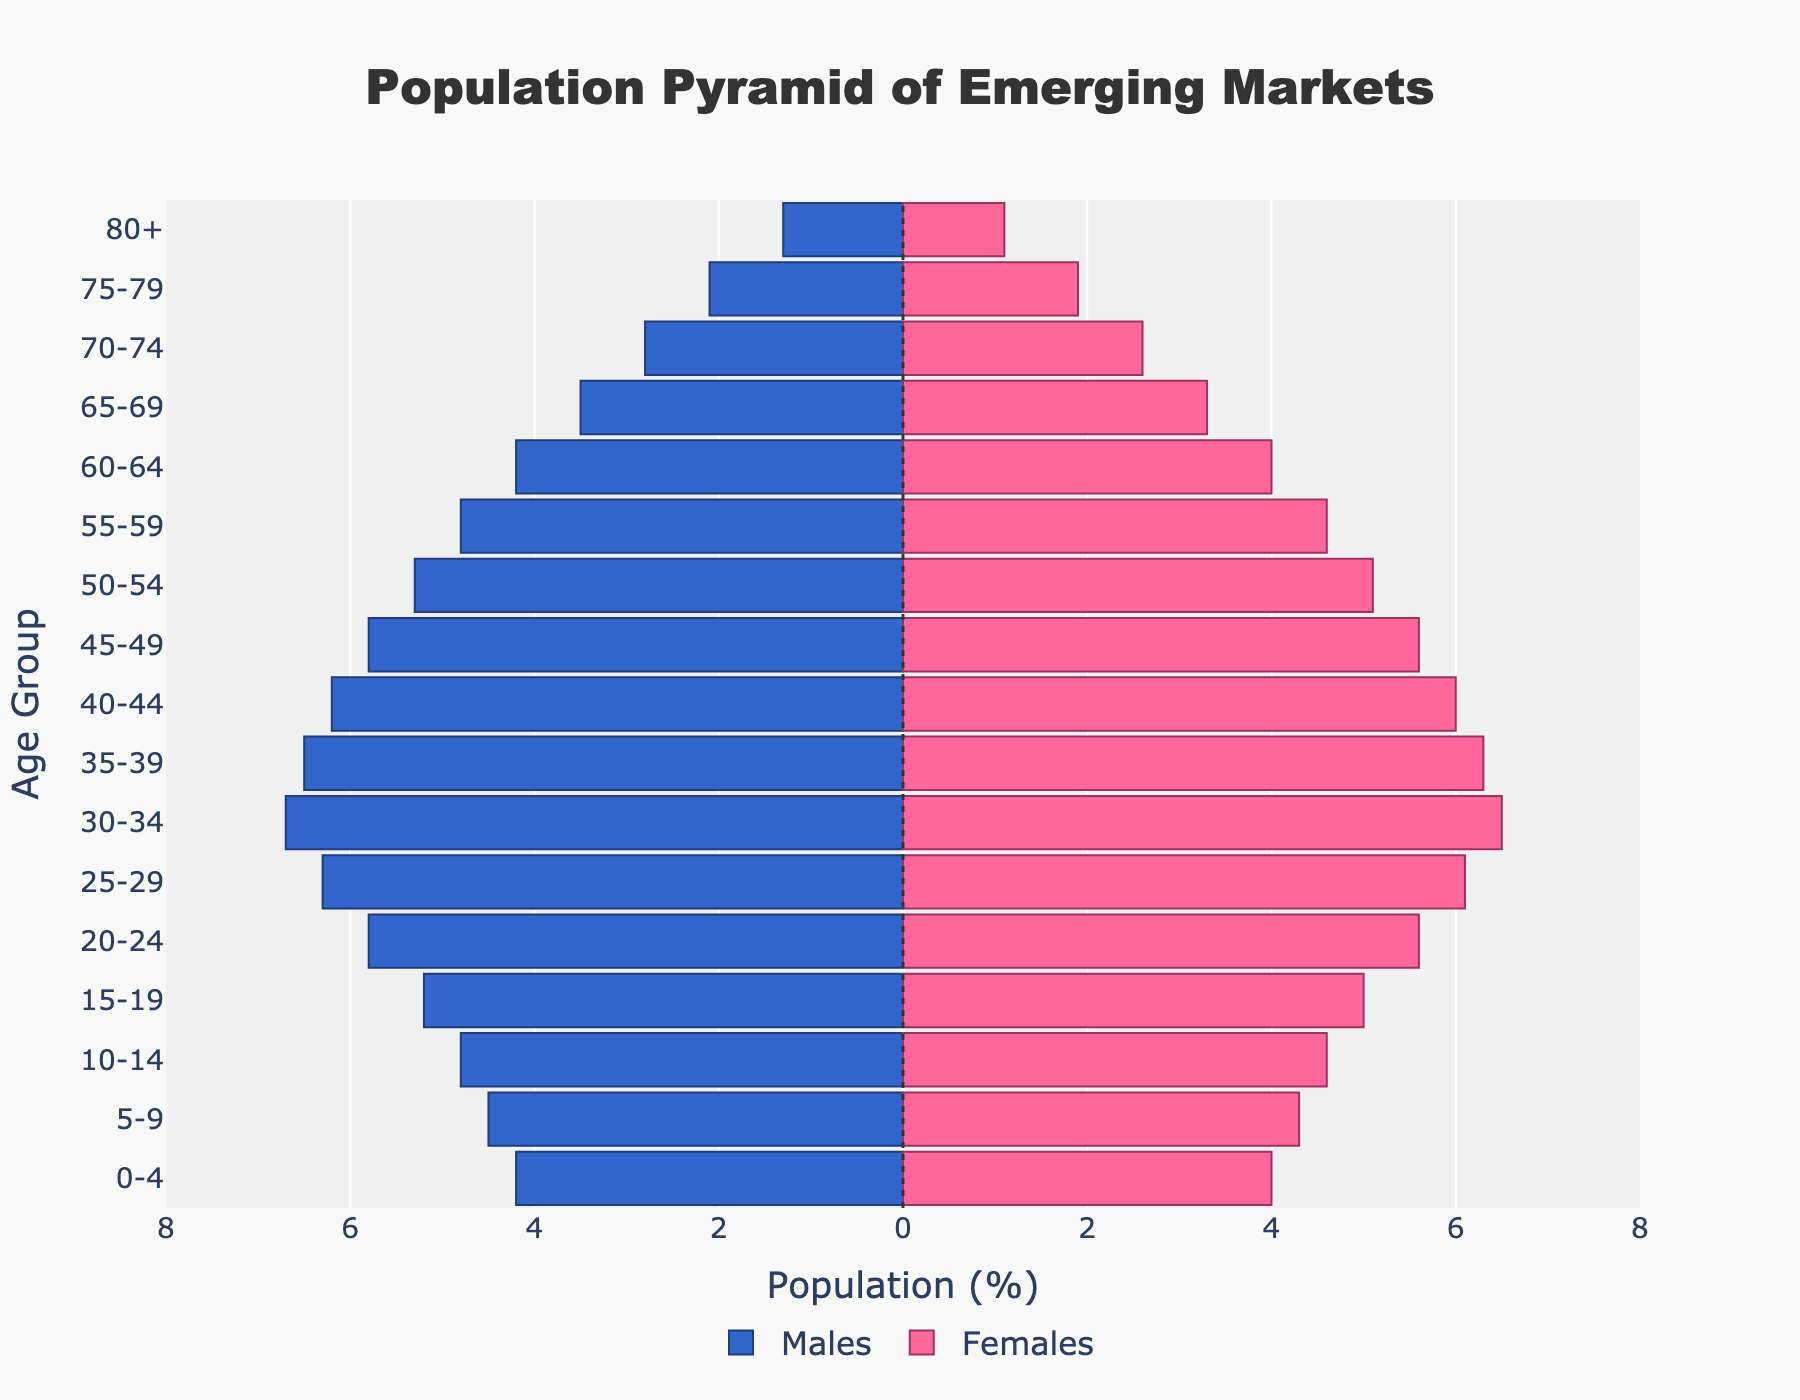what's the title of the figure? The title of the figure is located at the top and provides a summary of what the plot represents.
Answer: Population Pyramid of Emerging Markets Which age group has the highest population percentage for males? By looking at the longest horizontal bar on the left (negative values), we can identify the age group with the highest male population. The age group with the longest bar on the left side is 30-34.
Answer: 30-34 Compare the female population percentages of the 20-24 and 40-44 age groups. Which is higher? To determine this, we compare the lengths of the bars for females (right side) in the 20-24 age group and the 40-44 age group. The bar for 20-24 is longer than that for 40-44.
Answer: 20-24 What is the combined percentage of the working-age population (15-64) for females? Sum the percentages of the female population in age groups 15-19, 20-24, 25-29, 30-34, 35-39, 40-44, 45-49, 50-54, 55-59, and 60-64. The combined percentage is 5.0 + 5.6 + 6.1 + 6.5 + 6.3 + 6.0 + 5.6 + 5.1 + 4.6 + 4.0 = 54.8.
Answer: 54.8 Which age group has a more balanced population between males and females in percentage terms? To identify the most balanced age group, we need to find the age group where the difference between male and female percentages is the smallest. The age group 75-79 has males at 2.1% and females at 1.9%, yielding a difference of 0.2%, which is the smallest.
Answer: 75-79 What percentage of the population is aged 65 and over for males? Sum the percentages of the male population in age groups 65-69, 70-74, 75-79, and 80+. The combined percentage is 3.5 + 2.8 + 2.1 + 1.3 = 9.7.
Answer: 9.7 What is the difference in the population percentage of the 15-19 age group between males and females? Subtract the female percentage from the male percentage in the 15-19 age group. The male percentage is 5.2 and the female percentage is 5.0, so the difference is 5.2 - 5.0 = 0.2.
Answer: 0.2 Comparing all age groups, is there any age group where the percentage of females is higher than that of males? By analyzing the bars, we observe that in every age group, the percentage of males is either equal or higher than that of females.
Answer: No What is the overall trend in the population pyramid for emerging markets? The pyramid shows a broad base that gradually narrows towards the top, indicating a larger younger population and progressively fewer individuals in higher age groups. This trend is typical of emerging markets with high birth rates and lower life expectancy.
Answer: Younger population is larger 